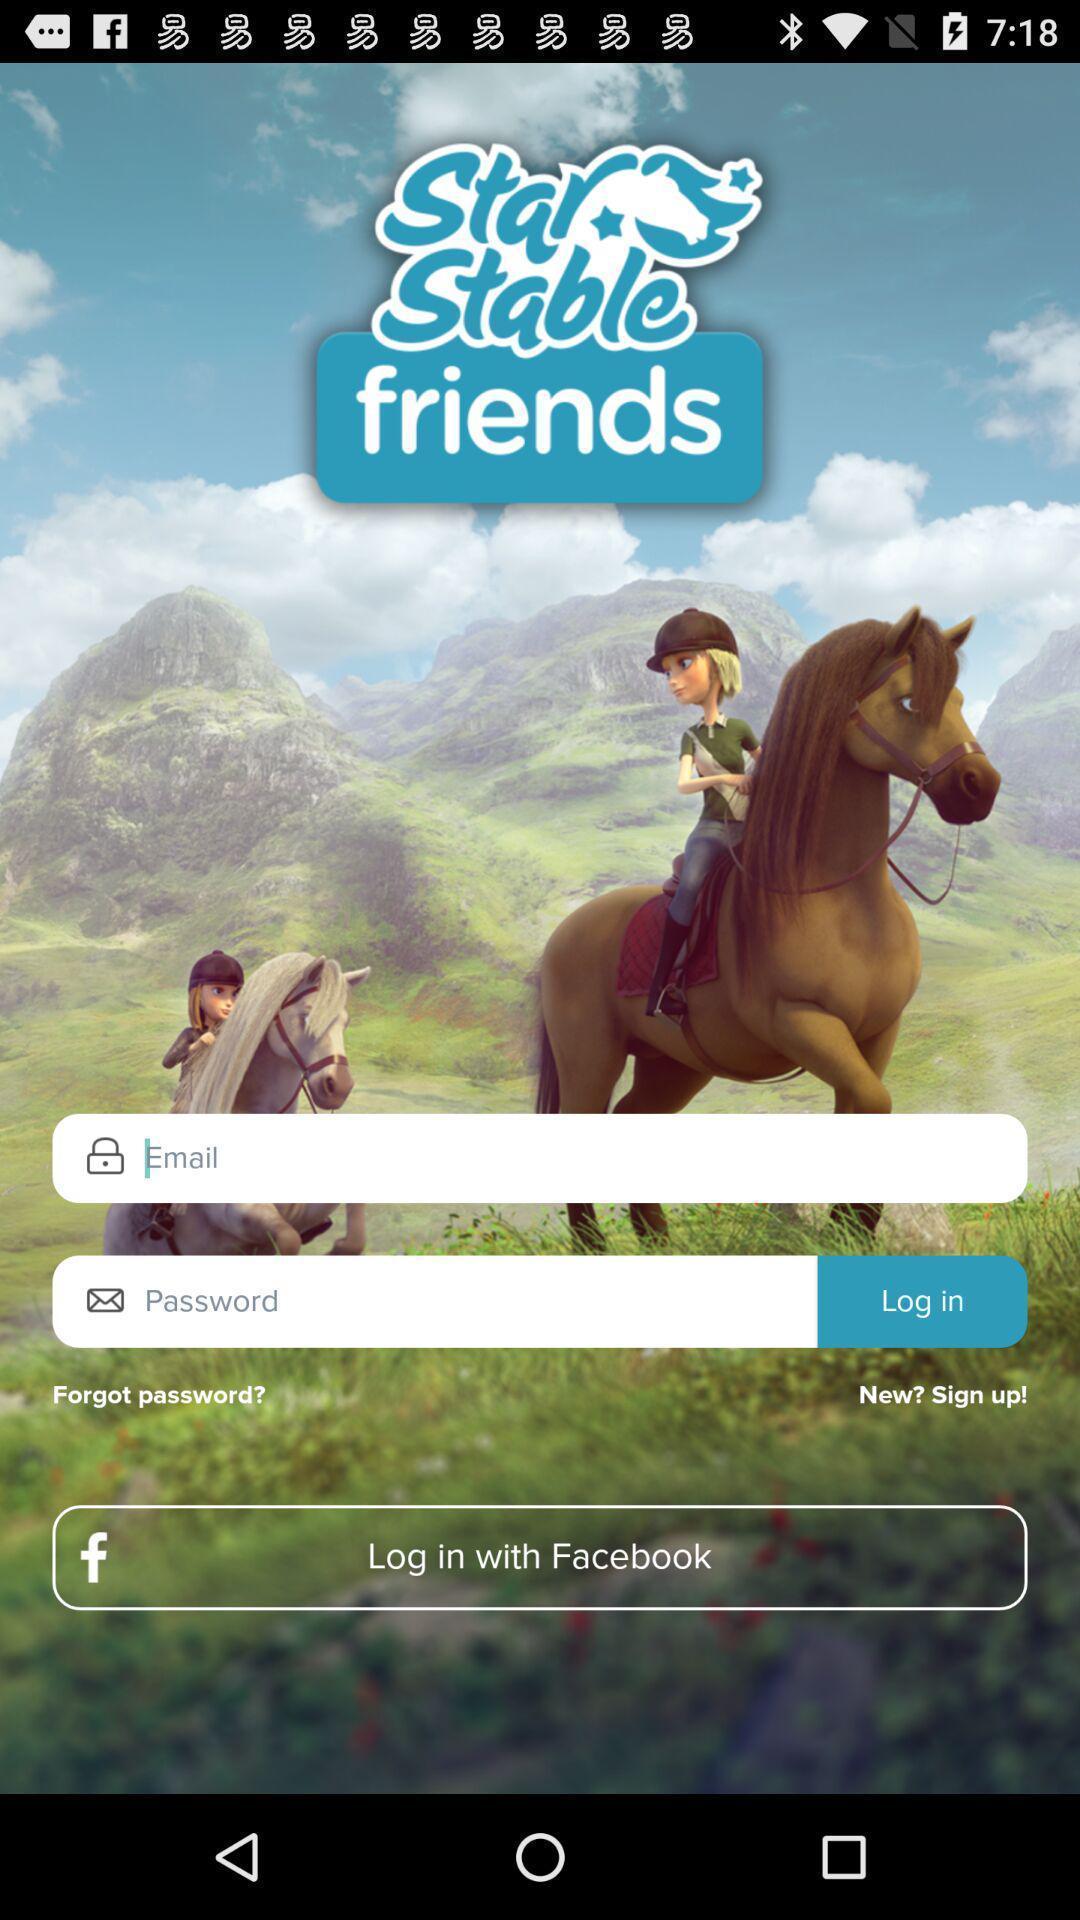What details can you identify in this image? Page showing login page. 